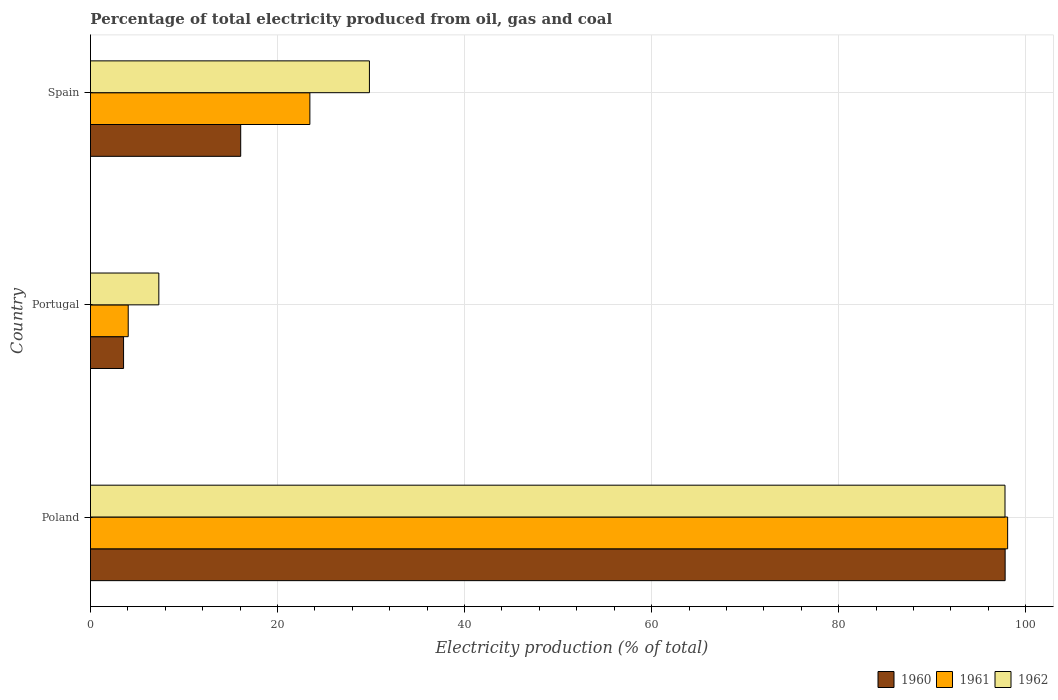How many groups of bars are there?
Your answer should be compact. 3. Are the number of bars on each tick of the Y-axis equal?
Your answer should be compact. Yes. What is the label of the 3rd group of bars from the top?
Offer a terse response. Poland. In how many cases, is the number of bars for a given country not equal to the number of legend labels?
Provide a succinct answer. 0. What is the electricity production in in 1960 in Portugal?
Offer a terse response. 3.54. Across all countries, what is the maximum electricity production in in 1961?
Provide a succinct answer. 98.07. Across all countries, what is the minimum electricity production in in 1960?
Provide a short and direct response. 3.54. What is the total electricity production in in 1962 in the graph?
Give a very brief answer. 134.92. What is the difference between the electricity production in in 1960 in Poland and that in Portugal?
Offer a very short reply. 94.26. What is the difference between the electricity production in in 1962 in Poland and the electricity production in in 1960 in Portugal?
Make the answer very short. 94.25. What is the average electricity production in in 1961 per country?
Ensure brevity in your answer.  41.85. What is the difference between the electricity production in in 1961 and electricity production in in 1962 in Spain?
Give a very brief answer. -6.37. In how many countries, is the electricity production in in 1960 greater than 12 %?
Provide a short and direct response. 2. What is the ratio of the electricity production in in 1961 in Poland to that in Portugal?
Provide a succinct answer. 24.3. Is the electricity production in in 1962 in Poland less than that in Spain?
Give a very brief answer. No. What is the difference between the highest and the second highest electricity production in in 1961?
Provide a short and direct response. 74.61. What is the difference between the highest and the lowest electricity production in in 1961?
Your response must be concise. 94.03. How many bars are there?
Keep it short and to the point. 9. Are all the bars in the graph horizontal?
Provide a succinct answer. Yes. Are the values on the major ticks of X-axis written in scientific E-notation?
Offer a very short reply. No. Does the graph contain any zero values?
Your answer should be very brief. No. Does the graph contain grids?
Provide a short and direct response. Yes. How are the legend labels stacked?
Provide a short and direct response. Horizontal. What is the title of the graph?
Provide a succinct answer. Percentage of total electricity produced from oil, gas and coal. What is the label or title of the X-axis?
Keep it short and to the point. Electricity production (% of total). What is the label or title of the Y-axis?
Keep it short and to the point. Country. What is the Electricity production (% of total) in 1960 in Poland?
Your response must be concise. 97.8. What is the Electricity production (% of total) in 1961 in Poland?
Your response must be concise. 98.07. What is the Electricity production (% of total) in 1962 in Poland?
Give a very brief answer. 97.79. What is the Electricity production (% of total) in 1960 in Portugal?
Provide a short and direct response. 3.54. What is the Electricity production (% of total) in 1961 in Portugal?
Your answer should be compact. 4.04. What is the Electricity production (% of total) in 1962 in Portugal?
Keep it short and to the point. 7.31. What is the Electricity production (% of total) in 1960 in Spain?
Provide a short and direct response. 16.06. What is the Electricity production (% of total) of 1961 in Spain?
Make the answer very short. 23.46. What is the Electricity production (% of total) in 1962 in Spain?
Offer a terse response. 29.83. Across all countries, what is the maximum Electricity production (% of total) in 1960?
Ensure brevity in your answer.  97.8. Across all countries, what is the maximum Electricity production (% of total) in 1961?
Offer a terse response. 98.07. Across all countries, what is the maximum Electricity production (% of total) in 1962?
Keep it short and to the point. 97.79. Across all countries, what is the minimum Electricity production (% of total) in 1960?
Keep it short and to the point. 3.54. Across all countries, what is the minimum Electricity production (% of total) in 1961?
Provide a succinct answer. 4.04. Across all countries, what is the minimum Electricity production (% of total) of 1962?
Your answer should be very brief. 7.31. What is the total Electricity production (% of total) of 1960 in the graph?
Your answer should be very brief. 117.4. What is the total Electricity production (% of total) of 1961 in the graph?
Provide a short and direct response. 125.56. What is the total Electricity production (% of total) of 1962 in the graph?
Give a very brief answer. 134.92. What is the difference between the Electricity production (% of total) in 1960 in Poland and that in Portugal?
Provide a short and direct response. 94.26. What is the difference between the Electricity production (% of total) of 1961 in Poland and that in Portugal?
Your answer should be very brief. 94.03. What is the difference between the Electricity production (% of total) of 1962 in Poland and that in Portugal?
Give a very brief answer. 90.48. What is the difference between the Electricity production (% of total) of 1960 in Poland and that in Spain?
Your answer should be compact. 81.74. What is the difference between the Electricity production (% of total) in 1961 in Poland and that in Spain?
Your response must be concise. 74.61. What is the difference between the Electricity production (% of total) of 1962 in Poland and that in Spain?
Make the answer very short. 67.96. What is the difference between the Electricity production (% of total) of 1960 in Portugal and that in Spain?
Give a very brief answer. -12.53. What is the difference between the Electricity production (% of total) in 1961 in Portugal and that in Spain?
Provide a succinct answer. -19.42. What is the difference between the Electricity production (% of total) of 1962 in Portugal and that in Spain?
Provide a short and direct response. -22.52. What is the difference between the Electricity production (% of total) in 1960 in Poland and the Electricity production (% of total) in 1961 in Portugal?
Offer a terse response. 93.76. What is the difference between the Electricity production (% of total) in 1960 in Poland and the Electricity production (% of total) in 1962 in Portugal?
Keep it short and to the point. 90.49. What is the difference between the Electricity production (% of total) in 1961 in Poland and the Electricity production (% of total) in 1962 in Portugal?
Your answer should be compact. 90.76. What is the difference between the Electricity production (% of total) of 1960 in Poland and the Electricity production (% of total) of 1961 in Spain?
Keep it short and to the point. 74.34. What is the difference between the Electricity production (% of total) of 1960 in Poland and the Electricity production (% of total) of 1962 in Spain?
Offer a very short reply. 67.97. What is the difference between the Electricity production (% of total) in 1961 in Poland and the Electricity production (% of total) in 1962 in Spain?
Your answer should be compact. 68.24. What is the difference between the Electricity production (% of total) in 1960 in Portugal and the Electricity production (% of total) in 1961 in Spain?
Offer a very short reply. -19.92. What is the difference between the Electricity production (% of total) of 1960 in Portugal and the Electricity production (% of total) of 1962 in Spain?
Give a very brief answer. -26.29. What is the difference between the Electricity production (% of total) of 1961 in Portugal and the Electricity production (% of total) of 1962 in Spain?
Keep it short and to the point. -25.79. What is the average Electricity production (% of total) of 1960 per country?
Ensure brevity in your answer.  39.13. What is the average Electricity production (% of total) in 1961 per country?
Give a very brief answer. 41.85. What is the average Electricity production (% of total) of 1962 per country?
Make the answer very short. 44.97. What is the difference between the Electricity production (% of total) of 1960 and Electricity production (% of total) of 1961 in Poland?
Provide a short and direct response. -0.27. What is the difference between the Electricity production (% of total) of 1960 and Electricity production (% of total) of 1962 in Poland?
Your response must be concise. 0.01. What is the difference between the Electricity production (% of total) in 1961 and Electricity production (% of total) in 1962 in Poland?
Provide a short and direct response. 0.28. What is the difference between the Electricity production (% of total) in 1960 and Electricity production (% of total) in 1961 in Portugal?
Provide a short and direct response. -0.5. What is the difference between the Electricity production (% of total) of 1960 and Electricity production (% of total) of 1962 in Portugal?
Provide a succinct answer. -3.77. What is the difference between the Electricity production (% of total) of 1961 and Electricity production (% of total) of 1962 in Portugal?
Give a very brief answer. -3.27. What is the difference between the Electricity production (% of total) in 1960 and Electricity production (% of total) in 1961 in Spain?
Ensure brevity in your answer.  -7.4. What is the difference between the Electricity production (% of total) in 1960 and Electricity production (% of total) in 1962 in Spain?
Make the answer very short. -13.76. What is the difference between the Electricity production (% of total) of 1961 and Electricity production (% of total) of 1962 in Spain?
Make the answer very short. -6.37. What is the ratio of the Electricity production (% of total) in 1960 in Poland to that in Portugal?
Your answer should be very brief. 27.65. What is the ratio of the Electricity production (% of total) of 1961 in Poland to that in Portugal?
Give a very brief answer. 24.3. What is the ratio of the Electricity production (% of total) of 1962 in Poland to that in Portugal?
Your response must be concise. 13.38. What is the ratio of the Electricity production (% of total) in 1960 in Poland to that in Spain?
Your response must be concise. 6.09. What is the ratio of the Electricity production (% of total) of 1961 in Poland to that in Spain?
Offer a terse response. 4.18. What is the ratio of the Electricity production (% of total) of 1962 in Poland to that in Spain?
Give a very brief answer. 3.28. What is the ratio of the Electricity production (% of total) of 1960 in Portugal to that in Spain?
Ensure brevity in your answer.  0.22. What is the ratio of the Electricity production (% of total) of 1961 in Portugal to that in Spain?
Your answer should be compact. 0.17. What is the ratio of the Electricity production (% of total) in 1962 in Portugal to that in Spain?
Provide a short and direct response. 0.24. What is the difference between the highest and the second highest Electricity production (% of total) of 1960?
Provide a short and direct response. 81.74. What is the difference between the highest and the second highest Electricity production (% of total) in 1961?
Ensure brevity in your answer.  74.61. What is the difference between the highest and the second highest Electricity production (% of total) in 1962?
Offer a terse response. 67.96. What is the difference between the highest and the lowest Electricity production (% of total) of 1960?
Provide a short and direct response. 94.26. What is the difference between the highest and the lowest Electricity production (% of total) in 1961?
Keep it short and to the point. 94.03. What is the difference between the highest and the lowest Electricity production (% of total) in 1962?
Your answer should be compact. 90.48. 